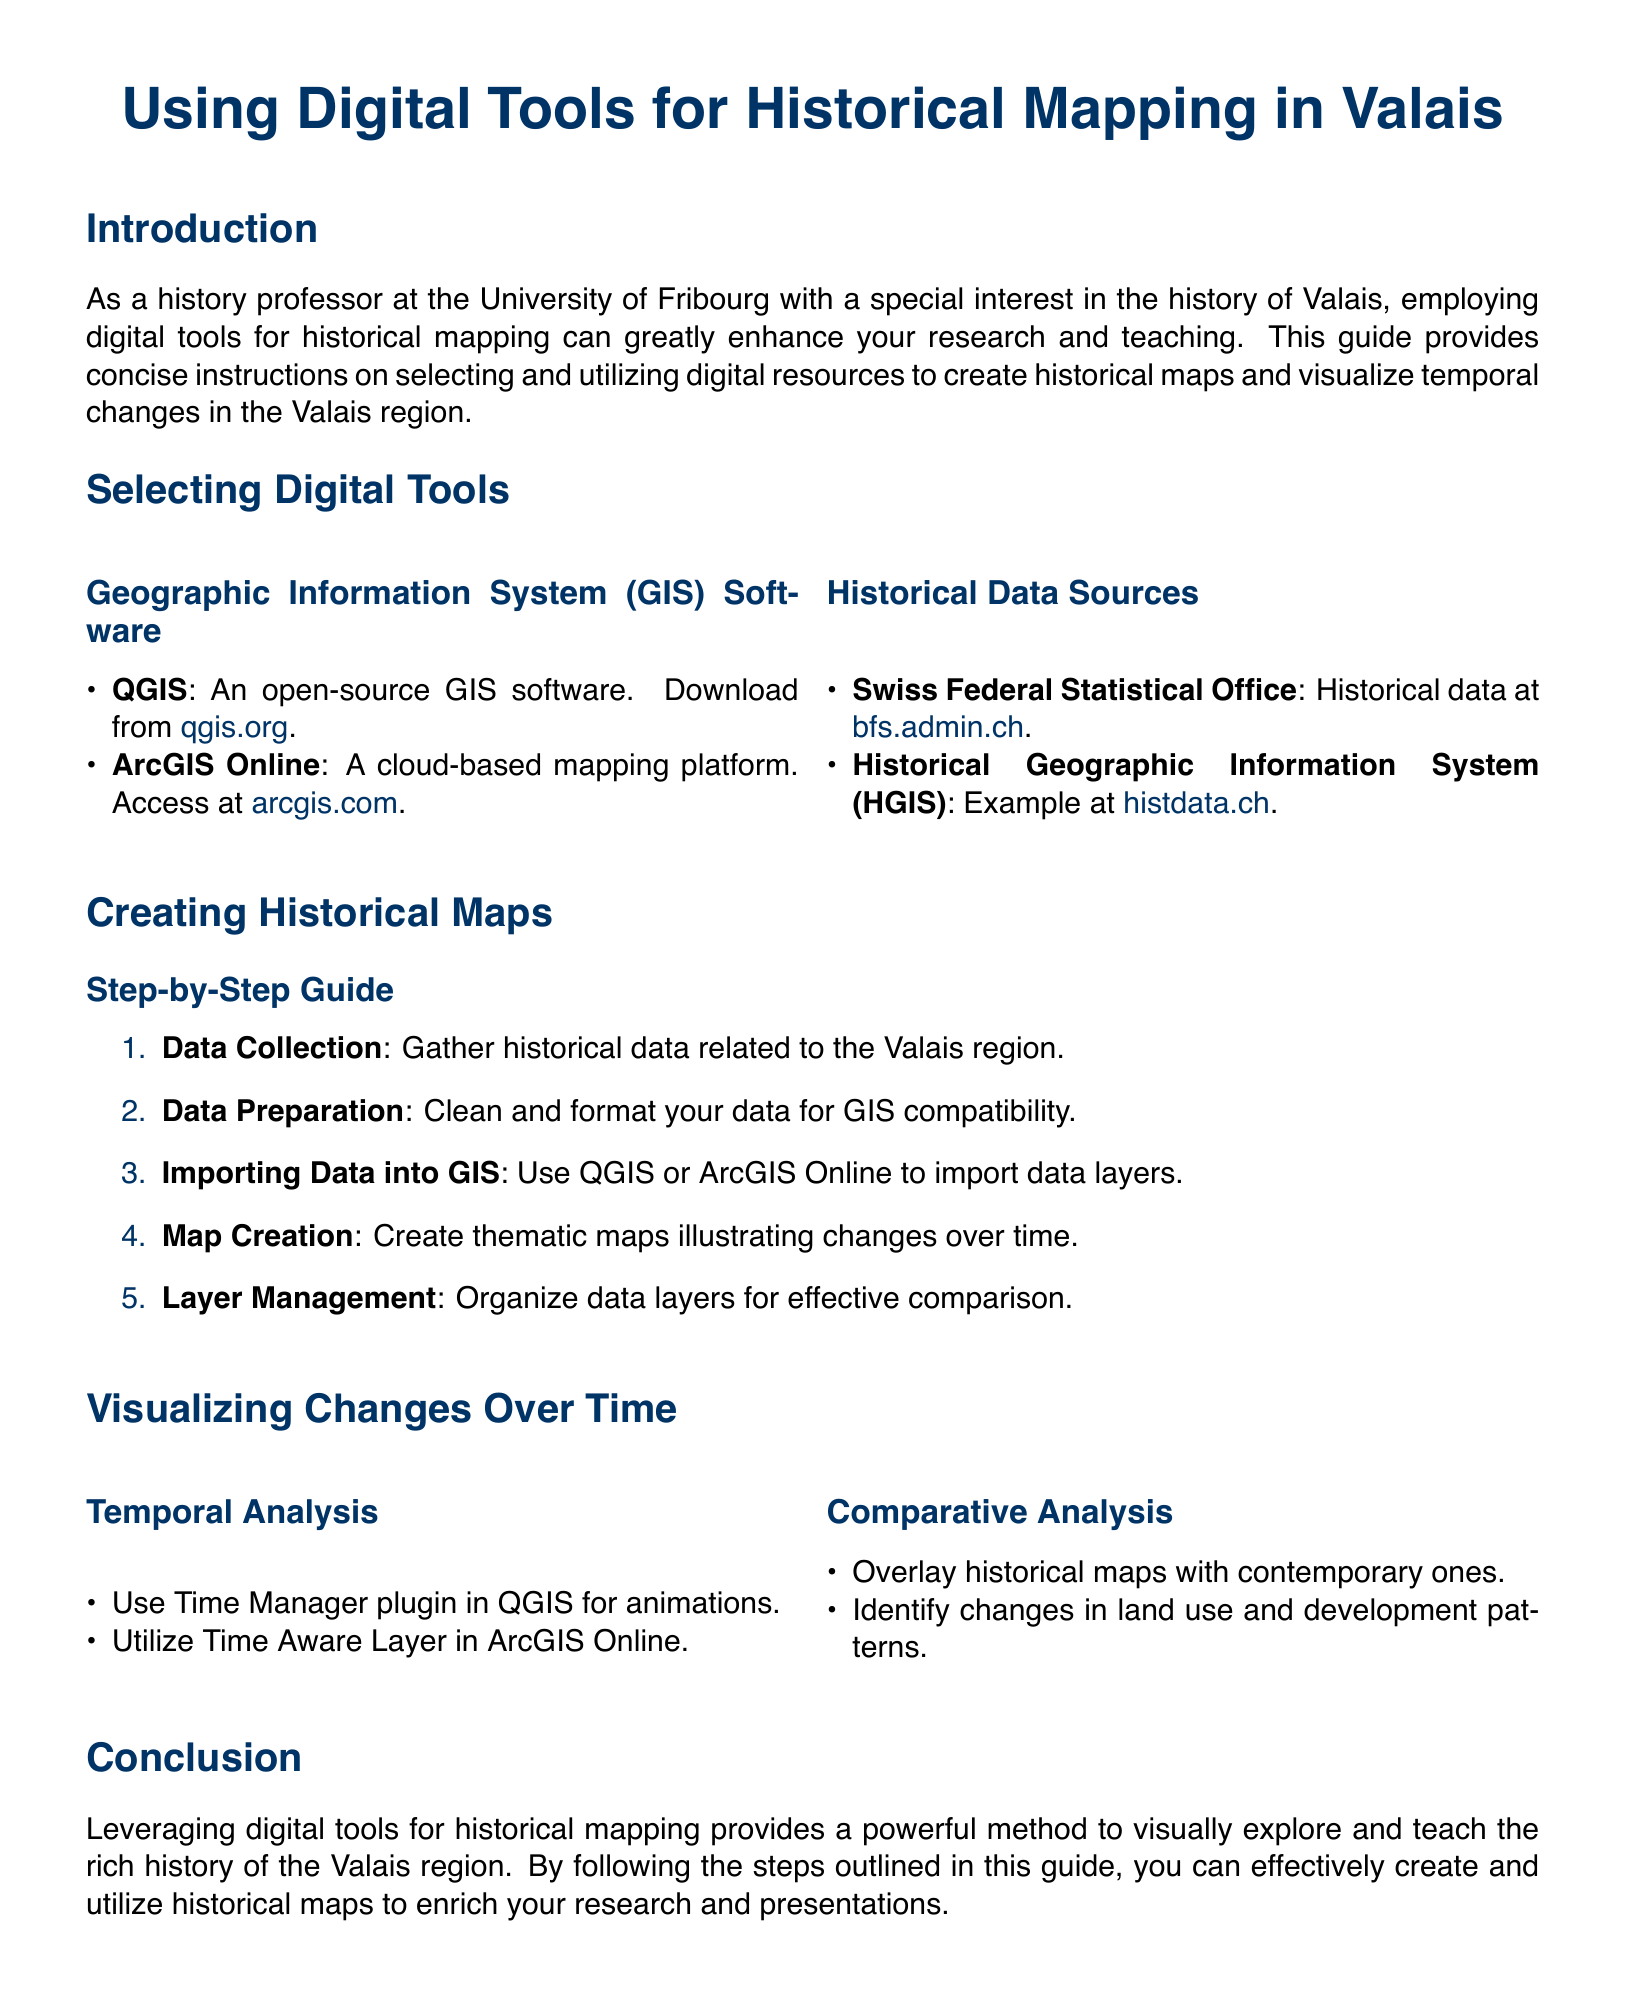What are the names of the two GIS software mentioned? The document lists QGIS and ArcGIS Online as the GIS software options.
Answer: QGIS and ArcGIS Online What is the purpose of using the Time Manager plugin in QGIS? The document states that the Time Manager plugin is used for animations in temporal analysis.
Answer: Animations Which website provides historical data for Valais? The Swiss Federal Statistical Office is indicated as a source for historical data.
Answer: bfs.admin.ch How many steps are in the guide for creating historical maps? The document outlines a step-by-step guide that includes five steps for creating historical maps.
Answer: Five What does the "Comparative Analysis" section suggest doing with historical maps? The document suggests overlaying historical maps with contemporary ones for comparative analysis.
Answer: Overlay What type of document is this? The document serves as a user guide providing instructions on digital tools for historical mapping.
Answer: User guide Which plugin is mentioned for use in QGIS to analyze temporal data? The plugin specifically mentioned for QGIS is the Time Manager plugin.
Answer: Time Manager Where can you access ArcGIS Online? The document provides the URL for ArcGIS Online as arcgis.com.
Answer: arcgis.com 